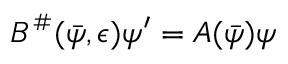Convert formula to latex. <formula><loc_0><loc_0><loc_500><loc_500>\begin{array} { r } { B ^ { \# } ( \bar { \psi } , \epsilon ) \psi ^ { \prime } = A ( \bar { \psi } ) \psi } \end{array}</formula> 